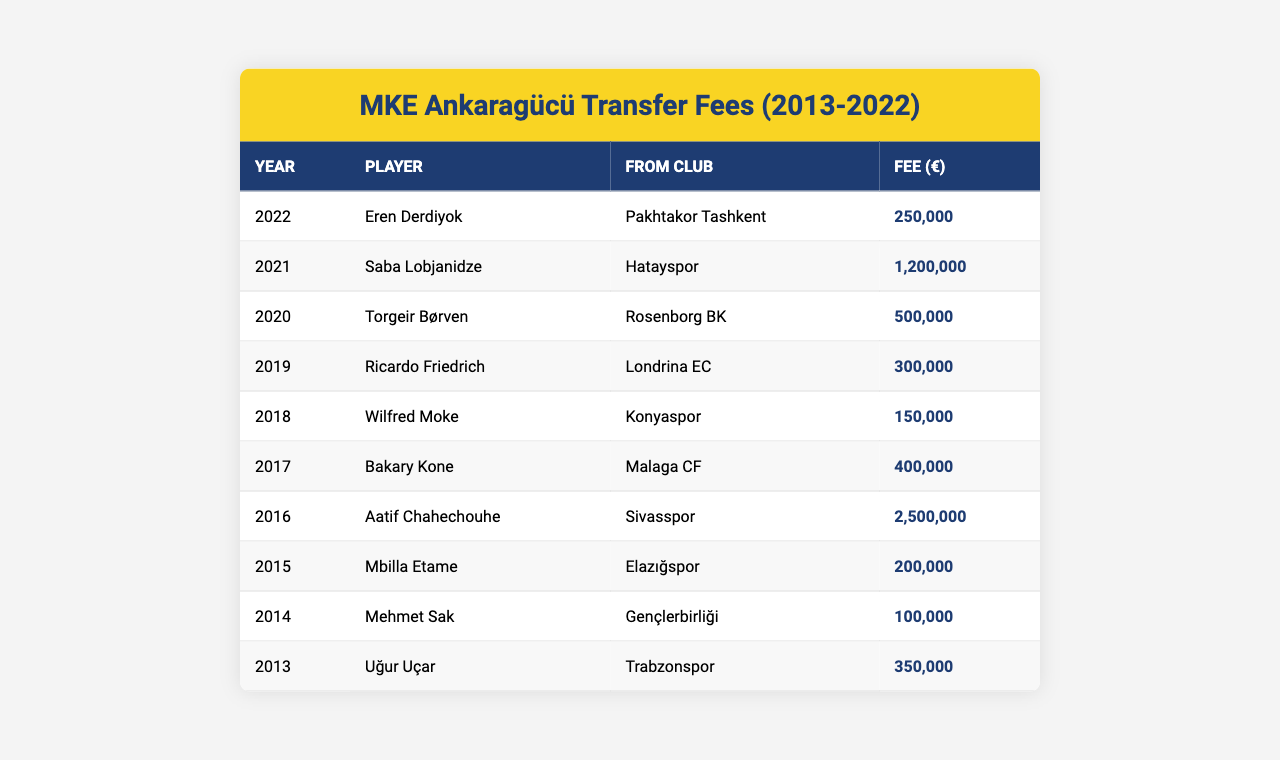What was the highest transfer fee paid by MKE Ankaragücü? Reviewing the table, the highest fee is found in 2016 for Aatif Chahechouhe at 2,500,000 euros.
Answer: 2,500,000 euros In what year did MKE Ankaragücü acquire Eren Derdiyok? Looking through the table, Eren Derdiyok was acquired in the year 2022.
Answer: 2022 Which player was transferred from Gençlerbirliği, and what was the fee? The table shows that Mehmet Sak was transferred from Gençlerbirliği for a fee of 100,000 euros.
Answer: Mehmet Sak, 100,000 euros How many players were acquired for more than 1,000,000 euros? Analyzing the table, I see that only one player, Saba Lobjanidze, was transferred for over 1,000,000 euros in 2021.
Answer: 1 player What is the total transfer fee paid for players in the years 2020 to 2022? To find this, I'll sum the fees from the table for the years 2020 (500,000), 2021 (1,200,000), and 2022 (250,000). Adding these gives 500,000 + 1,200,000 + 250,000 = 1,950,000 euros.
Answer: 1,950,000 euros Did MKE Ankaragücü pay a higher total fee in 2018 or 2019? In 2018, the fee was 150,000 euros, and in 2019 it was 300,000 euros. Since 300,000 is greater than 150,000, the total fee for 2019 is higher.
Answer: Yes, 2019 What is the average transfer fee for players acquired from clubs within Turkey? The relevant players are Wilfred Moke (150,000), Saba Lobjanidze (1,200,000), and Bakary Kone (400,000), acquired from Konyaspor, Hatayspor, and Malaga CF, respectively. Their fees sum up to 1,750,000 euros and dividing this by 3 gives an average of 583,333.33 euros.
Answer: 583,333 euros Which player had the second lowest transfer fee, and from which club did he come? By reviewing the table, the second lowest fee belongs to Ricardo Friedrich at 300,000 euros, coming from Londrina EC.
Answer: Ricardo Friedrich, Londrina EC Was there a transfer fee of exactly 250,000 euros? Checking the table, Eren Derdiyok and Aatif Chahechouhe had transfer fees of 250,000 euros. Therefore, it is true that such a fee exists.
Answer: Yes What is the fee difference between the highest and lowest transfer fees? The highest transfer fee is 2,500,000 euros (Aatif Chahechouhe in 2016) and the lowest is 100,000 euros (Mehmet Sak in 2014). The difference is 2,500,000 - 100,000 = 2,400,000 euros.
Answer: 2,400,000 euros 